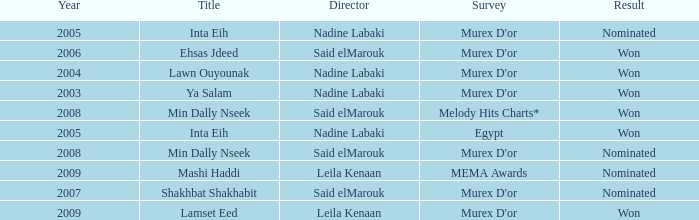What is the result for director Said Elmarouk before 2008? Won, Nominated. 